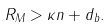Convert formula to latex. <formula><loc_0><loc_0><loc_500><loc_500>R _ { M } > \kappa n + d _ { b } .</formula> 